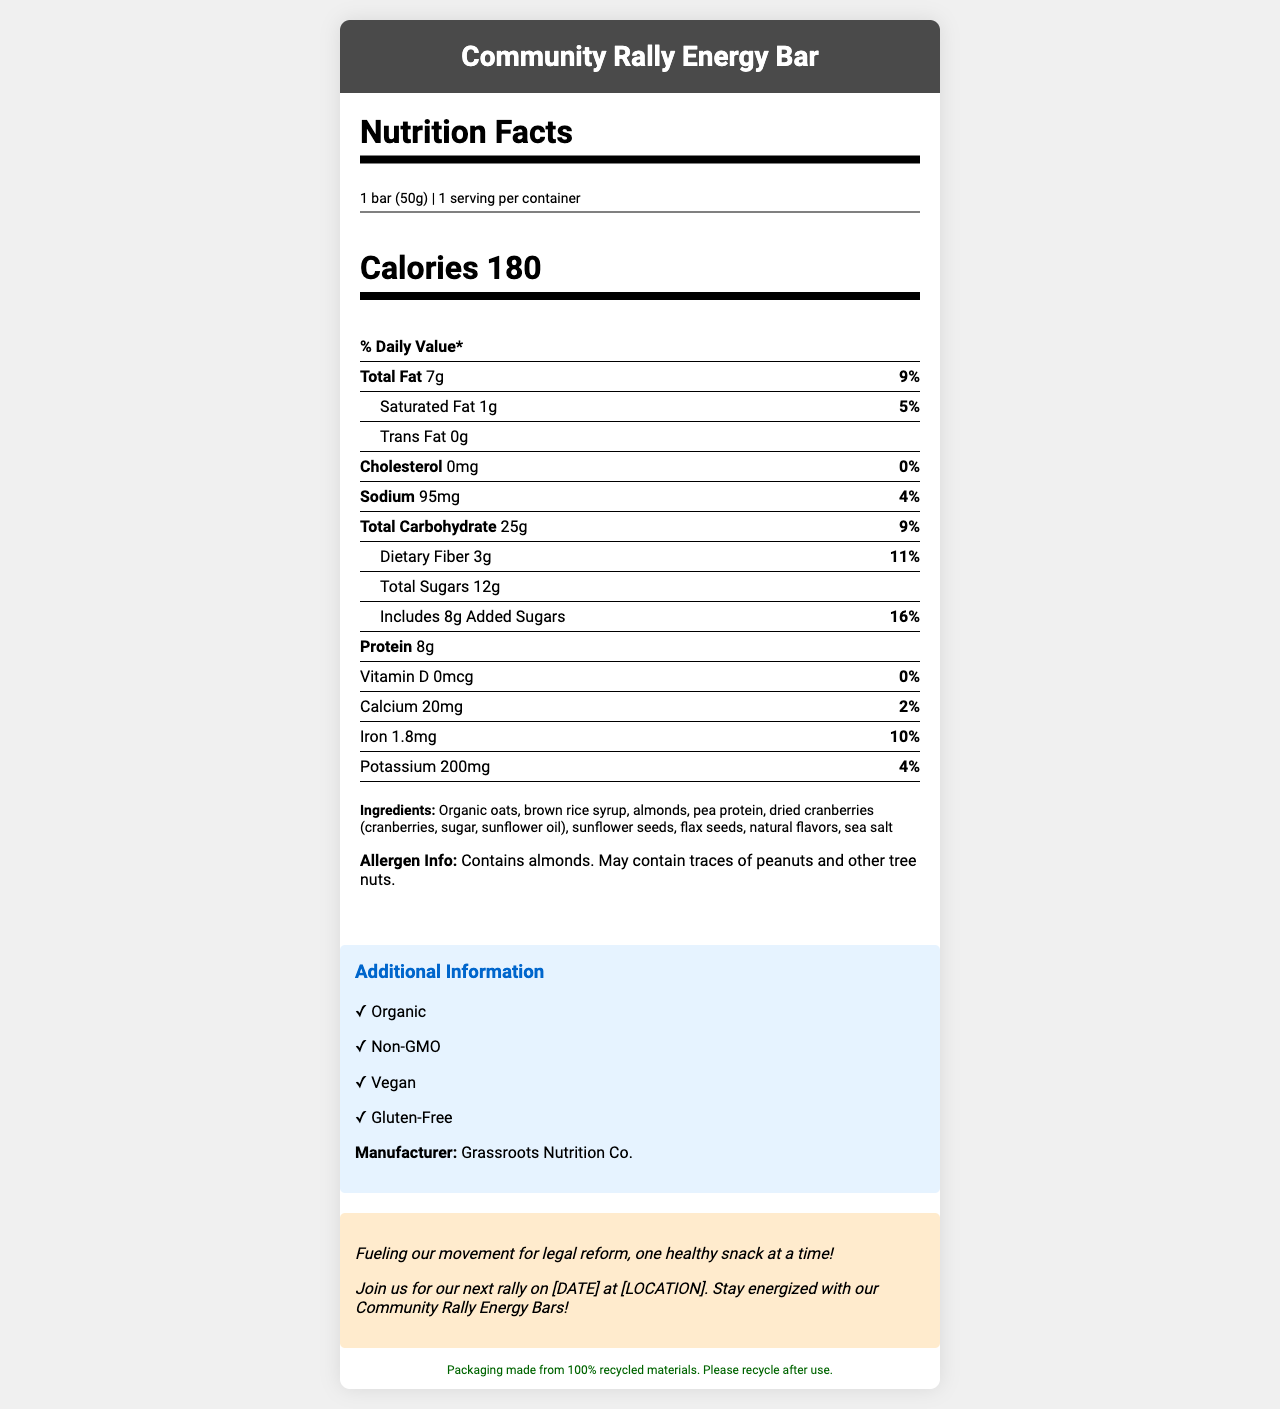what is the serving size of the Community Rally Energy Bar? The serving size is stated at the beginning of the Nutrition Facts section as "1 bar (50g)".
Answer: 1 bar (50g) how much protein does the Community Rally Energy Bar contain? The amount of protein is listed in the Nutrition Facts section as 8g.
Answer: 8g how many calories are in one serving of the Community Rally Energy Bar? The calories per serving are stated as 180 in the Nutrition Facts section.
Answer: 180 what percentage of the daily value for dietary fiber does the Community Rally Energy Bar provide? The document lists "Dietary Fiber 3g" and "11%" under the Total Carbohydrate section.
Answer: 11% how much sodium is in the Community Rally Energy Bar? The sodium content is listed as "95mg (4% Daily Value)" in the Nutrition Facts section.
Answer: 95mg which of these ingredients is not in the Community Rally Energy Bar? A. Almonds B. Honey C. Flax seeds D. Sunflower seeds The ingredient list includes almonds, flax seeds, and sunflower seeds, but not honey.
Answer: B. Honey what is the percentage daily value of calcium in the Community Rally Energy Bar? The calcium amount is listed as "20mg (2% Daily Value)" in the Nutrition Facts section.
Answer: 2% is the Community Rally Energy Bar gluten-free? The document's additional information section states that the bar is gluten-free.
Answer: Yes what type of fat does the Community Rally Energy Bar contain? A. Trans Fat B. Saturated Fat C. Both A and B The document lists "Saturated Fat 1g (5% Daily Value)" and "Trans Fat 0g", indicating it only contains saturated fat.
Answer: B. Saturated Fat what message does the Community Rally Energy Bar convey about the community? This community message is explicitly stated in the Community Message section.
Answer: Fueling our movement for legal reform, one healthy snack at a time! what is the name of the manufacturer of the Community Rally Energy Bar? The manufacturer’s name is listed in the Additional Information section.
Answer: Grassroots Nutrition Co. does the Community Rally Energy Bar contain any vitamin D? The amount of vitamin D is listed as "0mcg (0% Daily Value)" in the Nutrition Facts section.
Answer: No what allergens are present in the Community Rally Energy Bar? The allergen information is listed towards the end of the Nutrition Facts section.
Answer: Contains almonds. May contain traces of peanuts and other tree nuts. what additional attributes does the Community Rally Energy Bar have? This information is found in the Additional Information section.
Answer: Organic, Non-GMO, Vegan, Gluten-Free describe the main idea of the Nutrition Facts document for the Community Rally Energy Bar. The document thoroughly describes the nutritional facts, additional health attributes, and community-oriented messages associated with the Community Rally Energy Bar. It presents the bar as a healthy, sustainable snack that supports community rallies for legal reform.
Answer: The document details the nutritional content, ingredients, and allergen information of the Community Rally Energy Bar, highlighting its health benefits and suitability for various diets. It promotes the bar as organic, non-GMO, vegan, and gluten-free. The document also includes community messages about legal reform rallies and sustainability notes regarding the packaging. can you tell me the price of the Community Rally Energy Bar? The document provides detailed nutritional information, ingredients, and community messages but does not include the price.
Answer: Cannot be determined 